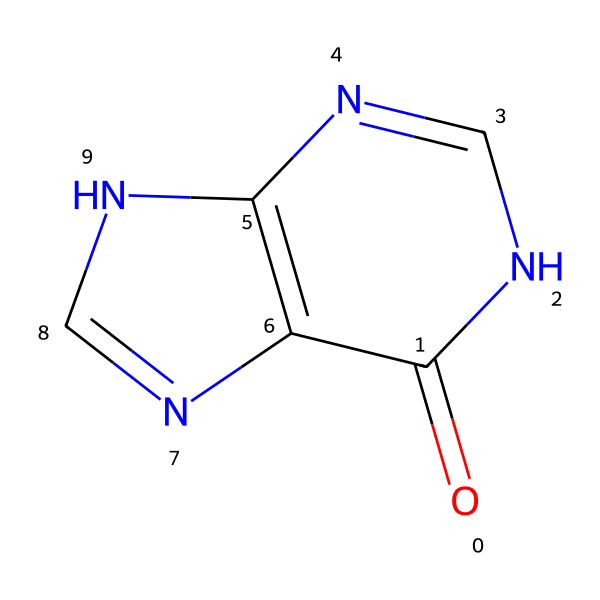How many nitrogen atoms are in this chemical? The chemical structure shows that there are three nitrogen atoms (N) present in the ring structure of the molecule. Counting the nitrogen atoms gives us the total.
Answer: three What is the total number of rings in the structure? The provided SMILES indicates a bicyclic structure, which consists of two interlinked rings. Analyzing the connections shows that there are two distinct cyclic systems present.
Answer: two What type of base does this structure represent? The presence of nitrogen and carbon atoms in rings is characteristic of purine bases in nucleic acids. Recognizing the specific structural features confirms it as a purine.
Answer: purine What functional group can be identified in this compound? The carbonyl group (C=O) is identifiable in the structure, indicating the presence of a carbonyl functional group which is a key characteristic.
Answer: carbonyl Which historical figure may share genetic material linked to this chemical structure? Notably, purines are found in DNA, and historical figures with notable genetic lineages may have genetic studies revealing similar structures in their DNA. The answer can vary based on specific research findings.
Answer: DNA 